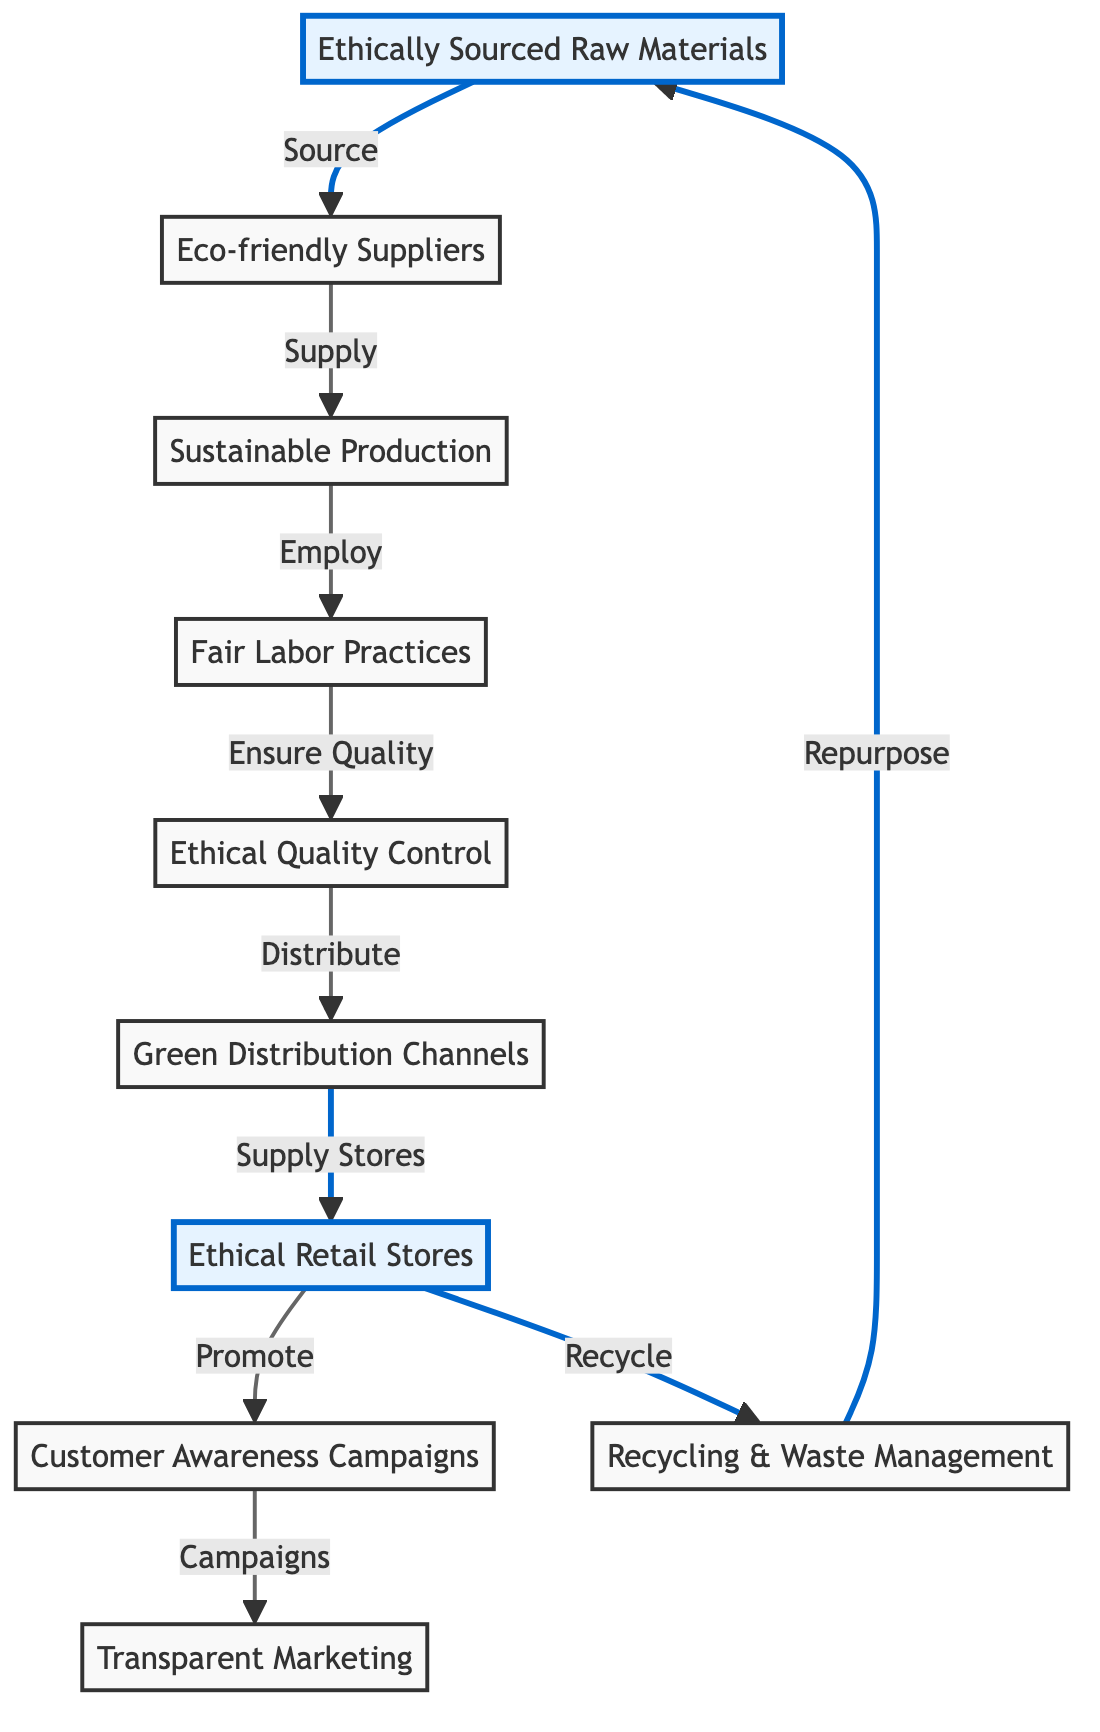What are the first nodes in the resource allocation flow? The first nodes are "Ethically Sourced Raw Materials" and "Eco-friendly Suppliers." The diagram starts with "Ethically Sourced Raw Materials," which directly connects to "Eco-friendly Suppliers."
Answer: Ethically Sourced Raw Materials, Eco-friendly Suppliers How many main steps are there in the ethical fashion process? By counting the nodes in the diagram (excluding the recycling loop), we find that there are six main steps from sourcing to marketing: raw materials, suppliers, production, labor, quality control, distribution, retail, and marketing.
Answer: Eight What connects "Quality Control" to "Green Distribution Channels"? The connecting arrow signifies that "Quality Control" ensures the quality before products are distributed through "Green Distribution Channels." This showcases the flow from quality assurance to distribution.
Answer: Ensure Quality Which node is directly linked to "Customer Awareness Campaigns"? The node directly linked to "Customer Awareness Campaigns" is "Ethical Retail Stores," which promotes awareness through campaigns. This indicates a direct promotional strategy from retail to customer engagement.
Answer: Ethical Retail Stores How does "Recycling & Waste Management" relate back to the initial step? The "Recycling & Waste Management" node is linked to "Ethically Sourced Raw Materials," indicating that the recycled materials might be repurposed into new raw materials, creating a circular process in resource allocation.
Answer: Repurpose What is the purpose of "Transparent Marketing" in this flow? "Transparent Marketing" is the final node that connects back to "Customer Awareness Campaigns," emphasizing the importance of clear communication and integrity about the ethical practices of the supply chain to customers.
Answer: Communication What type of suppliers are indicated in the diagram? The diagram specifies "Eco-friendly Suppliers," highlighting a commitment to sustainability in sourcing the raw materials needed for production.
Answer: Eco-friendly Suppliers Which process is indicated just before distribution? The diagram shows that "Ethical Quality Control" occurs just before the "Green Distribution Channels," signifying that quality checks are integral before products are passed along for distribution.
Answer: Quality Control 